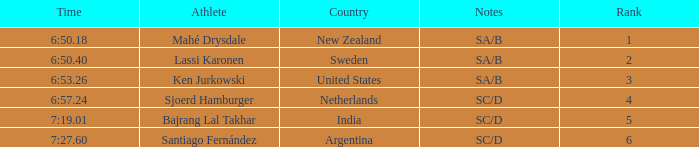What is the sum of the ranks for india? 5.0. 